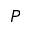<formula> <loc_0><loc_0><loc_500><loc_500>P</formula> 